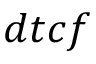<formula> <loc_0><loc_0><loc_500><loc_500>d t c f</formula> 